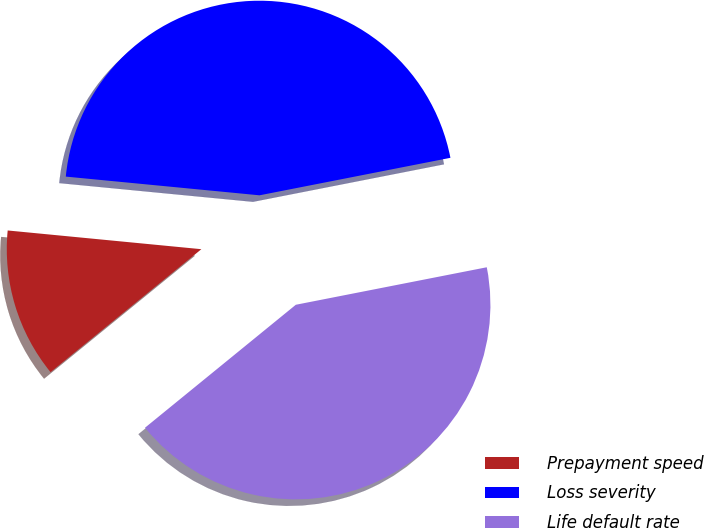<chart> <loc_0><loc_0><loc_500><loc_500><pie_chart><fcel>Prepayment speed<fcel>Loss severity<fcel>Life default rate<nl><fcel>12.42%<fcel>45.38%<fcel>42.2%<nl></chart> 